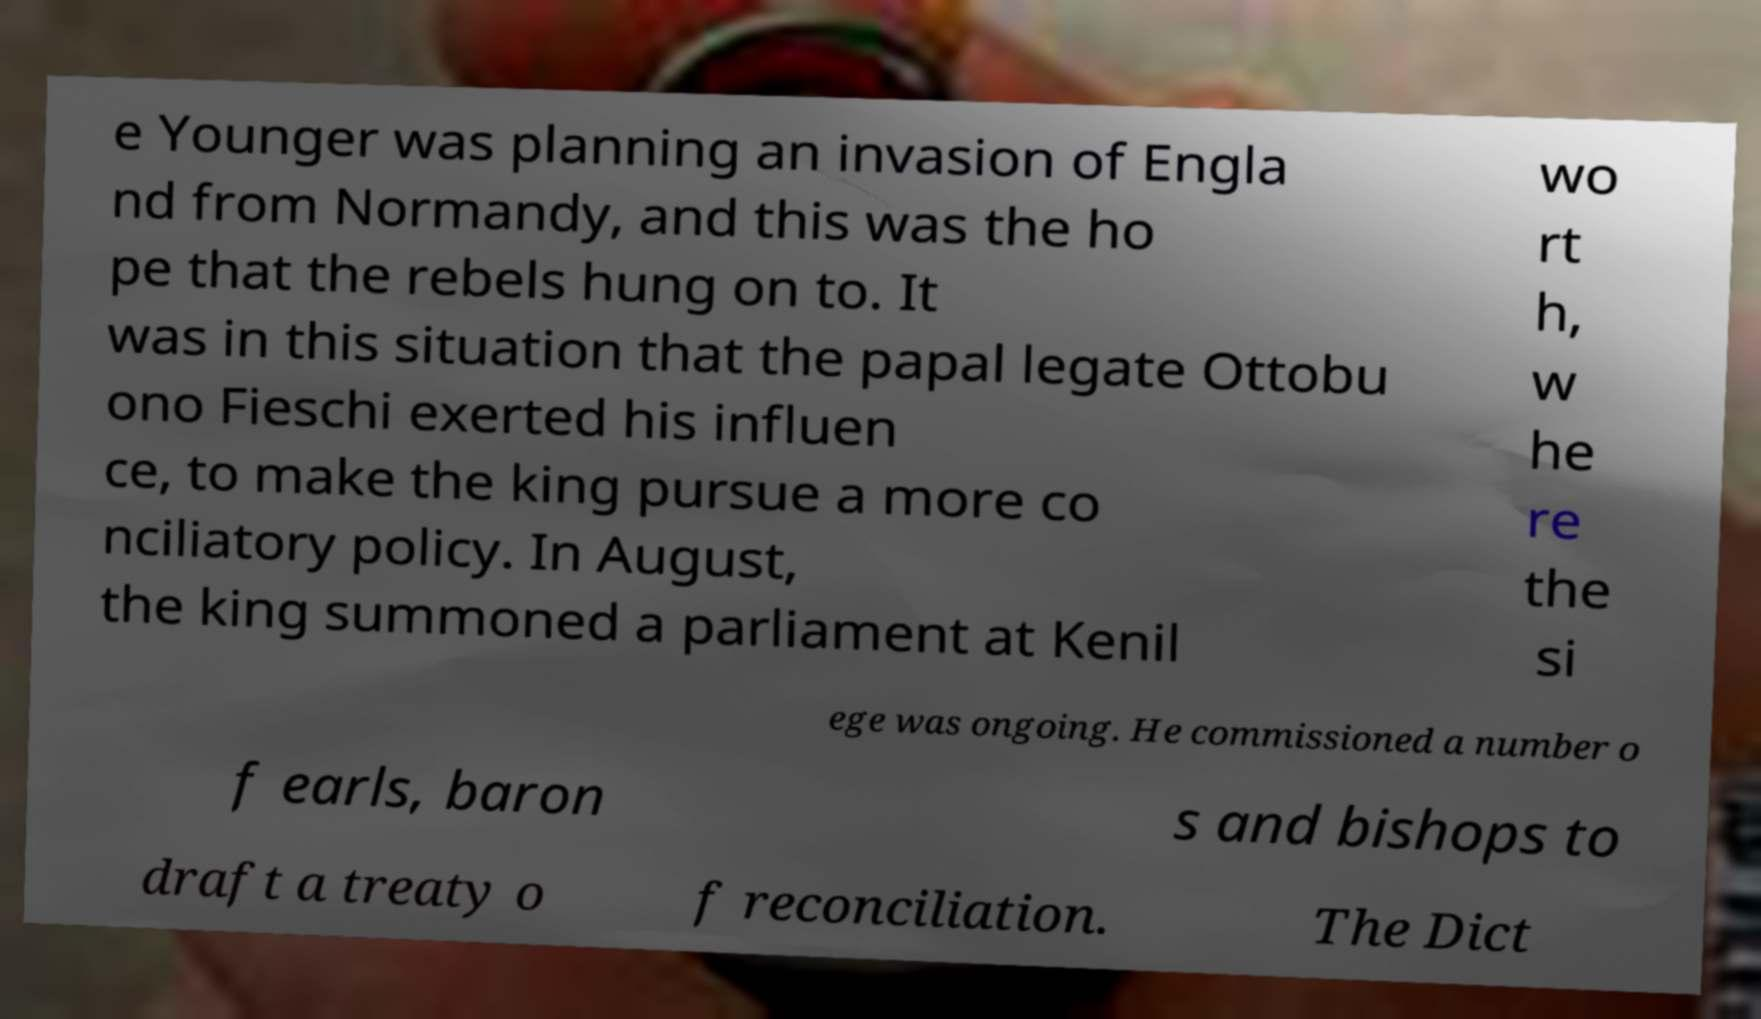Could you assist in decoding the text presented in this image and type it out clearly? e Younger was planning an invasion of Engla nd from Normandy, and this was the ho pe that the rebels hung on to. It was in this situation that the papal legate Ottobu ono Fieschi exerted his influen ce, to make the king pursue a more co nciliatory policy. In August, the king summoned a parliament at Kenil wo rt h, w he re the si ege was ongoing. He commissioned a number o f earls, baron s and bishops to draft a treaty o f reconciliation. The Dict 